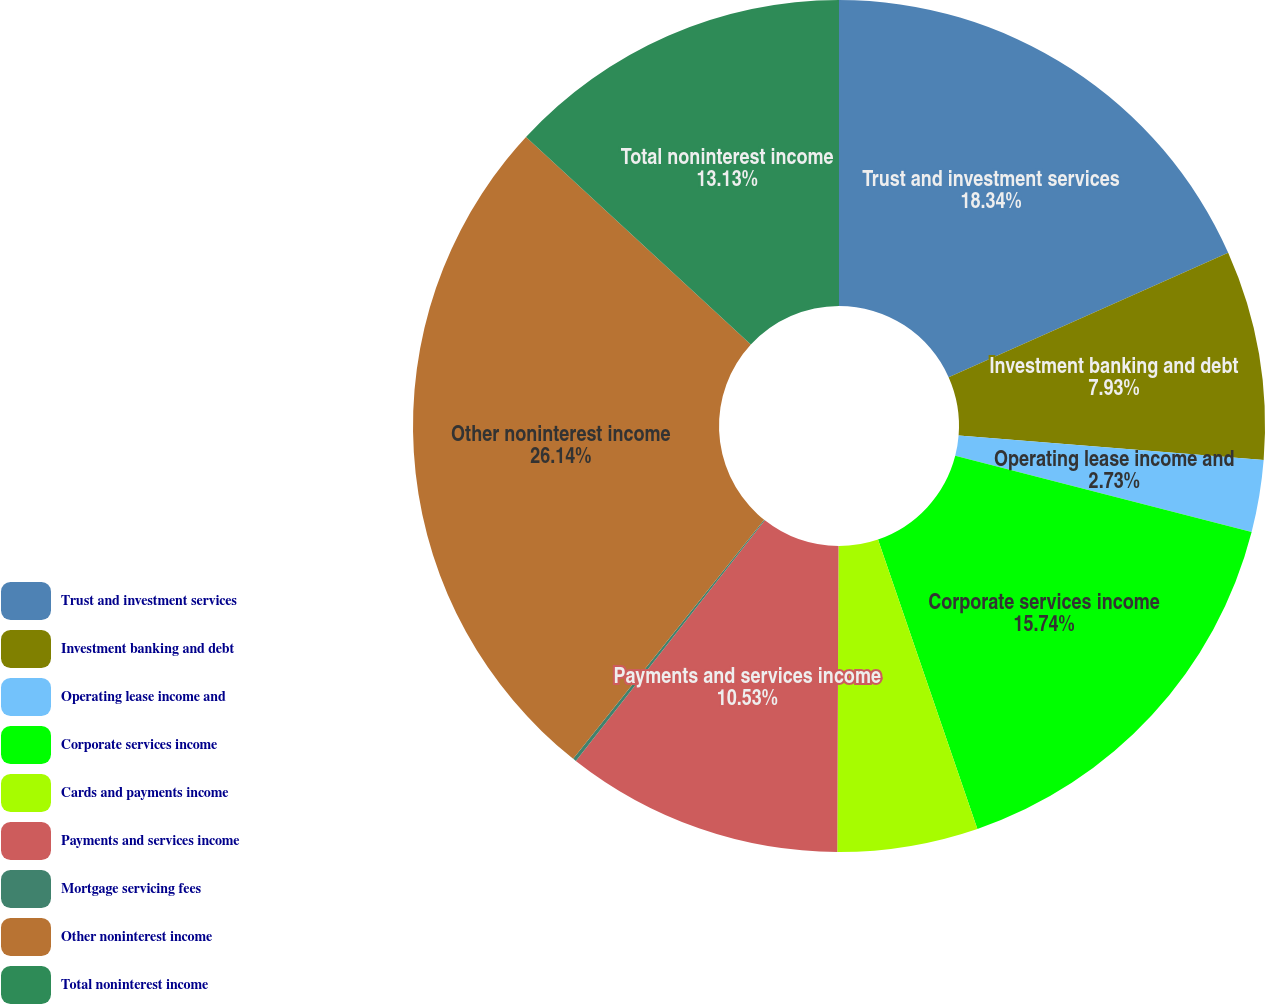<chart> <loc_0><loc_0><loc_500><loc_500><pie_chart><fcel>Trust and investment services<fcel>Investment banking and debt<fcel>Operating lease income and<fcel>Corporate services income<fcel>Cards and payments income<fcel>Payments and services income<fcel>Mortgage servicing fees<fcel>Other noninterest income<fcel>Total noninterest income<nl><fcel>18.33%<fcel>7.93%<fcel>2.73%<fcel>15.73%<fcel>5.33%<fcel>10.53%<fcel>0.13%<fcel>26.13%<fcel>13.13%<nl></chart> 